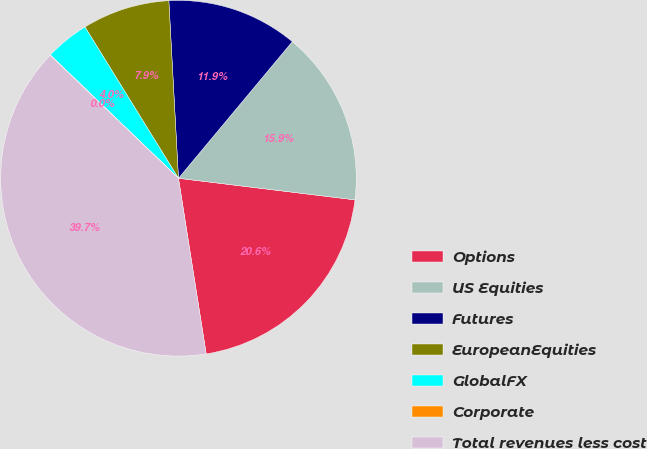Convert chart to OTSL. <chart><loc_0><loc_0><loc_500><loc_500><pie_chart><fcel>Options<fcel>US Equities<fcel>Futures<fcel>EuropeanEquities<fcel>GlobalFX<fcel>Corporate<fcel>Total revenues less cost<nl><fcel>20.57%<fcel>15.88%<fcel>11.92%<fcel>7.95%<fcel>3.99%<fcel>0.03%<fcel>39.66%<nl></chart> 